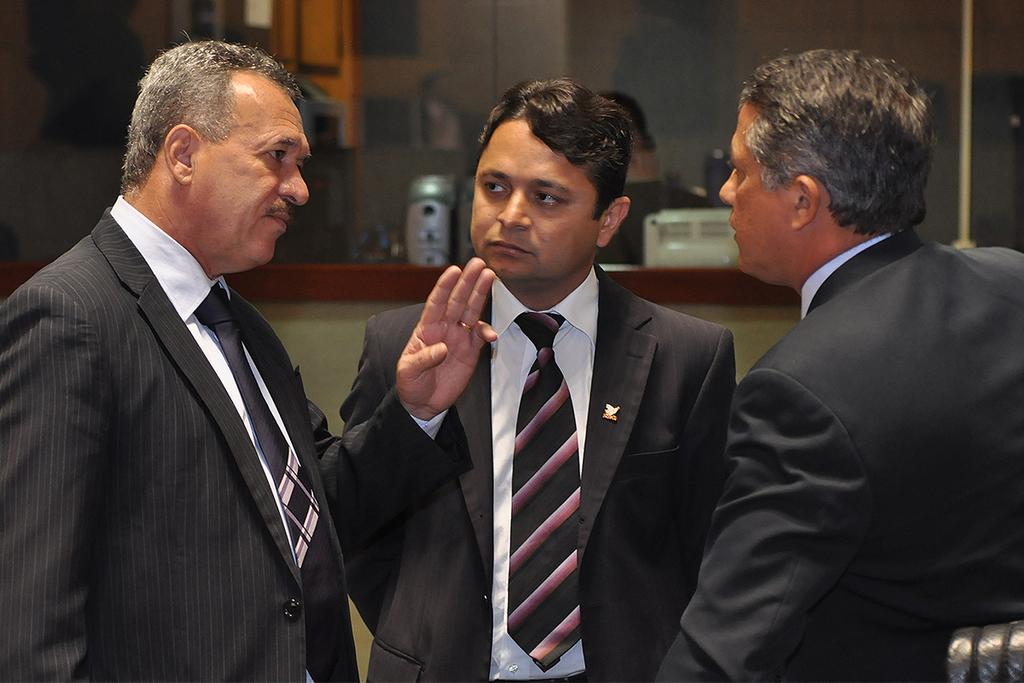How many people are present in the image? There are three persons standing in the image. Can you describe the positioning of the people? One person is standing at the back. What else can be seen in the image besides the people? There are objects in the image. Is there any indication of framed objects on the wall? There might be framed objects on the wall. What type of street is visible in the image? There is no street visible in the image; it features three persons standing with objects and potential framed objects on the wall. 